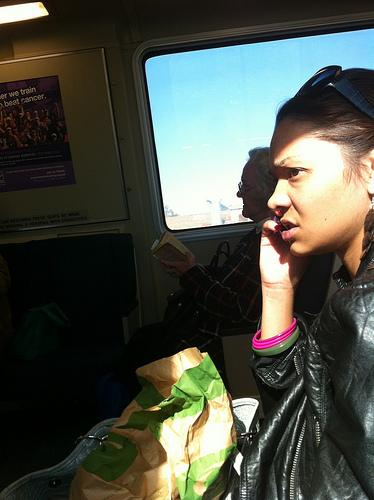Identify any advertisements seen in the image. There is a poster with an advertising and a white warning sign with black lettering on the wall of the train. Explain the situation of people sitting on the train. There are people sitting on the train including a woman talking on her cellphone, an old lady reading a book, and a man in the background. Describe the accessories the main subject is wearing. The girl is wearing pink and green plastic bracelets and has sunglasses placed on the top of her head. What is the main activity happening in the image? A girl is riding a train while talking on her cellphone. Tell me something about the woman sitting next to the main subject who is talking on the phone. An old lady is sitting next to the girl, reading a paperback book and holding a purse with leather straps. What can be seen through the window of the train? The edge of a window on the train is visible, but the outside view is not described in the image information. Please provide a brief description of the woman wearing sunglasses on top of her head. The woman is frowning, talking on a cellphone, wearing a black leather jacket, and has pink and green bracelets on her wrist. Find the man in the background and describe his actions. The man in the background is reading a book, and only his face profile is visible. Describe the bag on the girl's lap. There's a brown and green paper bag in the girl's lap, possibly holding a parcel. Look for a red umbrella next to the woman on the phone. No, it's not mentioned in the image. Where is the dog sitting under the seat on the train? There is no information about a dog or any animal being present in the image. This instruction is misleading because it asks a question about a nonexistent object in the image. 